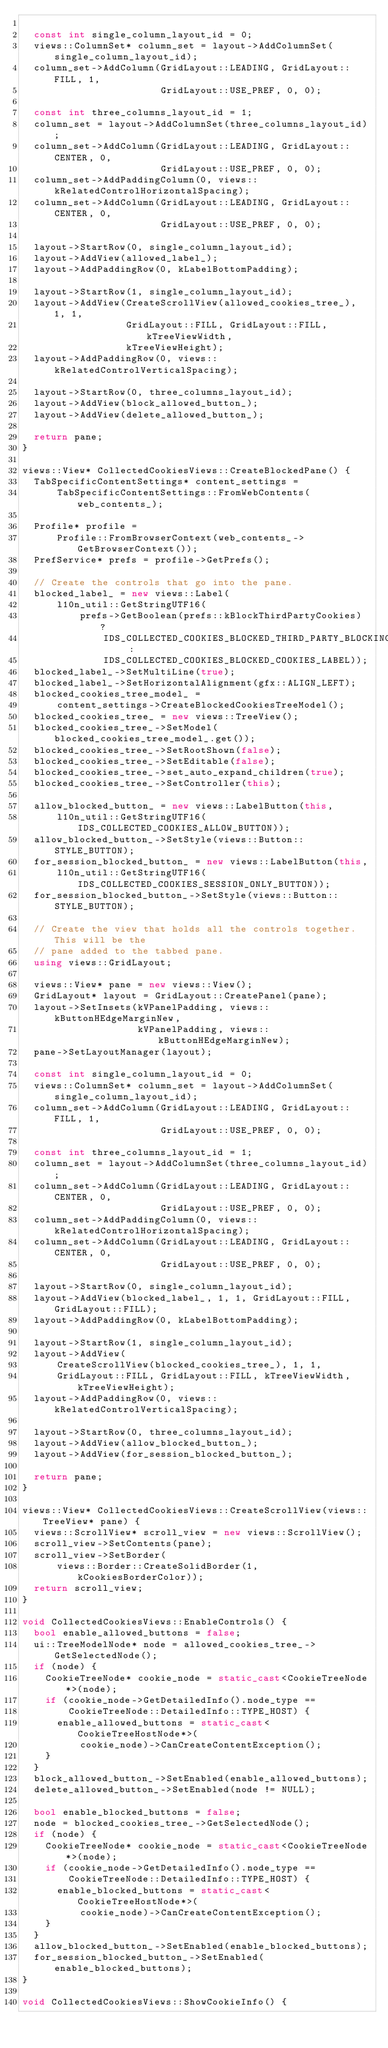<code> <loc_0><loc_0><loc_500><loc_500><_C++_>
  const int single_column_layout_id = 0;
  views::ColumnSet* column_set = layout->AddColumnSet(single_column_layout_id);
  column_set->AddColumn(GridLayout::LEADING, GridLayout::FILL, 1,
                        GridLayout::USE_PREF, 0, 0);

  const int three_columns_layout_id = 1;
  column_set = layout->AddColumnSet(three_columns_layout_id);
  column_set->AddColumn(GridLayout::LEADING, GridLayout::CENTER, 0,
                        GridLayout::USE_PREF, 0, 0);
  column_set->AddPaddingColumn(0, views::kRelatedControlHorizontalSpacing);
  column_set->AddColumn(GridLayout::LEADING, GridLayout::CENTER, 0,
                        GridLayout::USE_PREF, 0, 0);

  layout->StartRow(0, single_column_layout_id);
  layout->AddView(allowed_label_);
  layout->AddPaddingRow(0, kLabelBottomPadding);

  layout->StartRow(1, single_column_layout_id);
  layout->AddView(CreateScrollView(allowed_cookies_tree_), 1, 1,
                  GridLayout::FILL, GridLayout::FILL, kTreeViewWidth,
                  kTreeViewHeight);
  layout->AddPaddingRow(0, views::kRelatedControlVerticalSpacing);

  layout->StartRow(0, three_columns_layout_id);
  layout->AddView(block_allowed_button_);
  layout->AddView(delete_allowed_button_);

  return pane;
}

views::View* CollectedCookiesViews::CreateBlockedPane() {
  TabSpecificContentSettings* content_settings =
      TabSpecificContentSettings::FromWebContents(web_contents_);

  Profile* profile =
      Profile::FromBrowserContext(web_contents_->GetBrowserContext());
  PrefService* prefs = profile->GetPrefs();

  // Create the controls that go into the pane.
  blocked_label_ = new views::Label(
      l10n_util::GetStringUTF16(
          prefs->GetBoolean(prefs::kBlockThirdPartyCookies) ?
              IDS_COLLECTED_COOKIES_BLOCKED_THIRD_PARTY_BLOCKING_ENABLED :
              IDS_COLLECTED_COOKIES_BLOCKED_COOKIES_LABEL));
  blocked_label_->SetMultiLine(true);
  blocked_label_->SetHorizontalAlignment(gfx::ALIGN_LEFT);
  blocked_cookies_tree_model_ =
      content_settings->CreateBlockedCookiesTreeModel();
  blocked_cookies_tree_ = new views::TreeView();
  blocked_cookies_tree_->SetModel(blocked_cookies_tree_model_.get());
  blocked_cookies_tree_->SetRootShown(false);
  blocked_cookies_tree_->SetEditable(false);
  blocked_cookies_tree_->set_auto_expand_children(true);
  blocked_cookies_tree_->SetController(this);

  allow_blocked_button_ = new views::LabelButton(this,
      l10n_util::GetStringUTF16(IDS_COLLECTED_COOKIES_ALLOW_BUTTON));
  allow_blocked_button_->SetStyle(views::Button::STYLE_BUTTON);
  for_session_blocked_button_ = new views::LabelButton(this,
      l10n_util::GetStringUTF16(IDS_COLLECTED_COOKIES_SESSION_ONLY_BUTTON));
  for_session_blocked_button_->SetStyle(views::Button::STYLE_BUTTON);

  // Create the view that holds all the controls together.  This will be the
  // pane added to the tabbed pane.
  using views::GridLayout;

  views::View* pane = new views::View();
  GridLayout* layout = GridLayout::CreatePanel(pane);
  layout->SetInsets(kVPanelPadding, views::kButtonHEdgeMarginNew,
                    kVPanelPadding, views::kButtonHEdgeMarginNew);
  pane->SetLayoutManager(layout);

  const int single_column_layout_id = 0;
  views::ColumnSet* column_set = layout->AddColumnSet(single_column_layout_id);
  column_set->AddColumn(GridLayout::LEADING, GridLayout::FILL, 1,
                        GridLayout::USE_PREF, 0, 0);

  const int three_columns_layout_id = 1;
  column_set = layout->AddColumnSet(three_columns_layout_id);
  column_set->AddColumn(GridLayout::LEADING, GridLayout::CENTER, 0,
                        GridLayout::USE_PREF, 0, 0);
  column_set->AddPaddingColumn(0, views::kRelatedControlHorizontalSpacing);
  column_set->AddColumn(GridLayout::LEADING, GridLayout::CENTER, 0,
                        GridLayout::USE_PREF, 0, 0);

  layout->StartRow(0, single_column_layout_id);
  layout->AddView(blocked_label_, 1, 1, GridLayout::FILL, GridLayout::FILL);
  layout->AddPaddingRow(0, kLabelBottomPadding);

  layout->StartRow(1, single_column_layout_id);
  layout->AddView(
      CreateScrollView(blocked_cookies_tree_), 1, 1,
      GridLayout::FILL, GridLayout::FILL, kTreeViewWidth, kTreeViewHeight);
  layout->AddPaddingRow(0, views::kRelatedControlVerticalSpacing);

  layout->StartRow(0, three_columns_layout_id);
  layout->AddView(allow_blocked_button_);
  layout->AddView(for_session_blocked_button_);

  return pane;
}

views::View* CollectedCookiesViews::CreateScrollView(views::TreeView* pane) {
  views::ScrollView* scroll_view = new views::ScrollView();
  scroll_view->SetContents(pane);
  scroll_view->SetBorder(
      views::Border::CreateSolidBorder(1, kCookiesBorderColor));
  return scroll_view;
}

void CollectedCookiesViews::EnableControls() {
  bool enable_allowed_buttons = false;
  ui::TreeModelNode* node = allowed_cookies_tree_->GetSelectedNode();
  if (node) {
    CookieTreeNode* cookie_node = static_cast<CookieTreeNode*>(node);
    if (cookie_node->GetDetailedInfo().node_type ==
        CookieTreeNode::DetailedInfo::TYPE_HOST) {
      enable_allowed_buttons = static_cast<CookieTreeHostNode*>(
          cookie_node)->CanCreateContentException();
    }
  }
  block_allowed_button_->SetEnabled(enable_allowed_buttons);
  delete_allowed_button_->SetEnabled(node != NULL);

  bool enable_blocked_buttons = false;
  node = blocked_cookies_tree_->GetSelectedNode();
  if (node) {
    CookieTreeNode* cookie_node = static_cast<CookieTreeNode*>(node);
    if (cookie_node->GetDetailedInfo().node_type ==
        CookieTreeNode::DetailedInfo::TYPE_HOST) {
      enable_blocked_buttons = static_cast<CookieTreeHostNode*>(
          cookie_node)->CanCreateContentException();
    }
  }
  allow_blocked_button_->SetEnabled(enable_blocked_buttons);
  for_session_blocked_button_->SetEnabled(enable_blocked_buttons);
}

void CollectedCookiesViews::ShowCookieInfo() {</code> 